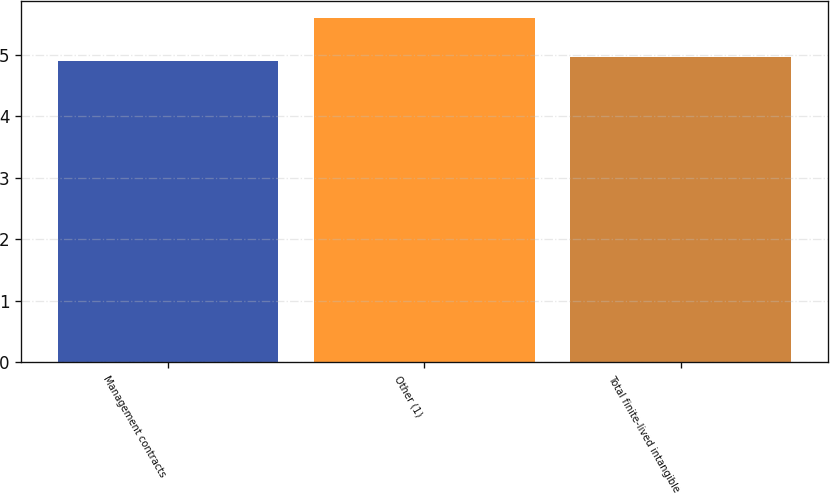Convert chart to OTSL. <chart><loc_0><loc_0><loc_500><loc_500><bar_chart><fcel>Management contracts<fcel>Other (1)<fcel>Total finite-lived intangible<nl><fcel>4.9<fcel>5.6<fcel>4.97<nl></chart> 